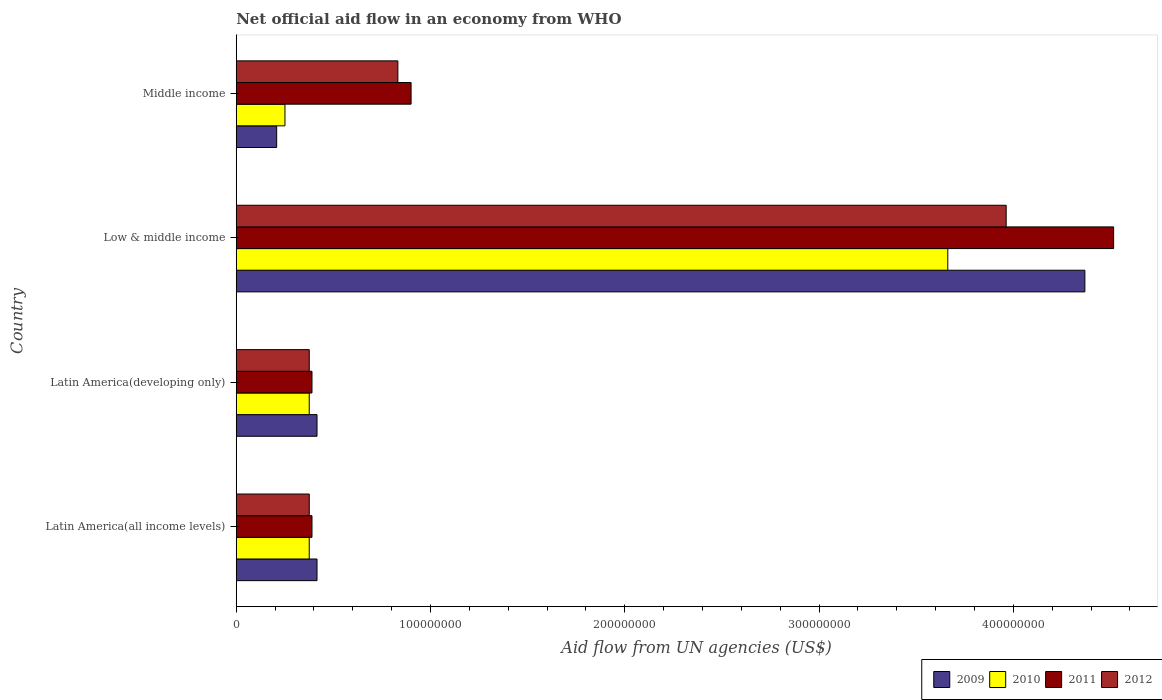Are the number of bars on each tick of the Y-axis equal?
Ensure brevity in your answer.  Yes. How many bars are there on the 2nd tick from the top?
Your answer should be very brief. 4. What is the label of the 3rd group of bars from the top?
Your answer should be very brief. Latin America(developing only). In how many cases, is the number of bars for a given country not equal to the number of legend labels?
Provide a succinct answer. 0. What is the net official aid flow in 2012 in Latin America(all income levels)?
Your answer should be compact. 3.76e+07. Across all countries, what is the maximum net official aid flow in 2009?
Offer a terse response. 4.37e+08. Across all countries, what is the minimum net official aid flow in 2012?
Offer a terse response. 3.76e+07. In which country was the net official aid flow in 2009 maximum?
Offer a very short reply. Low & middle income. In which country was the net official aid flow in 2009 minimum?
Provide a succinct answer. Middle income. What is the total net official aid flow in 2009 in the graph?
Keep it short and to the point. 5.41e+08. What is the difference between the net official aid flow in 2010 in Latin America(all income levels) and that in Low & middle income?
Your answer should be very brief. -3.29e+08. What is the difference between the net official aid flow in 2009 in Latin America(developing only) and the net official aid flow in 2011 in Low & middle income?
Your response must be concise. -4.10e+08. What is the average net official aid flow in 2010 per country?
Make the answer very short. 1.17e+08. What is the difference between the net official aid flow in 2012 and net official aid flow in 2011 in Low & middle income?
Your answer should be very brief. -5.53e+07. What is the ratio of the net official aid flow in 2010 in Low & middle income to that in Middle income?
Make the answer very short. 14.61. What is the difference between the highest and the second highest net official aid flow in 2010?
Your answer should be very brief. 3.29e+08. What is the difference between the highest and the lowest net official aid flow in 2011?
Ensure brevity in your answer.  4.13e+08. Is the sum of the net official aid flow in 2009 in Low & middle income and Middle income greater than the maximum net official aid flow in 2011 across all countries?
Ensure brevity in your answer.  Yes. Is it the case that in every country, the sum of the net official aid flow in 2010 and net official aid flow in 2011 is greater than the sum of net official aid flow in 2009 and net official aid flow in 2012?
Your response must be concise. No. What does the 4th bar from the top in Latin America(developing only) represents?
Provide a short and direct response. 2009. What does the 3rd bar from the bottom in Latin America(developing only) represents?
Provide a short and direct response. 2011. Is it the case that in every country, the sum of the net official aid flow in 2011 and net official aid flow in 2009 is greater than the net official aid flow in 2012?
Your response must be concise. Yes. How many bars are there?
Make the answer very short. 16. Are all the bars in the graph horizontal?
Keep it short and to the point. Yes. Does the graph contain any zero values?
Your answer should be compact. No. What is the title of the graph?
Offer a terse response. Net official aid flow in an economy from WHO. What is the label or title of the X-axis?
Give a very brief answer. Aid flow from UN agencies (US$). What is the label or title of the Y-axis?
Provide a succinct answer. Country. What is the Aid flow from UN agencies (US$) of 2009 in Latin America(all income levels)?
Offer a very short reply. 4.16e+07. What is the Aid flow from UN agencies (US$) of 2010 in Latin America(all income levels)?
Give a very brief answer. 3.76e+07. What is the Aid flow from UN agencies (US$) in 2011 in Latin America(all income levels)?
Offer a terse response. 3.90e+07. What is the Aid flow from UN agencies (US$) of 2012 in Latin America(all income levels)?
Your answer should be compact. 3.76e+07. What is the Aid flow from UN agencies (US$) of 2009 in Latin America(developing only)?
Offer a terse response. 4.16e+07. What is the Aid flow from UN agencies (US$) of 2010 in Latin America(developing only)?
Provide a short and direct response. 3.76e+07. What is the Aid flow from UN agencies (US$) of 2011 in Latin America(developing only)?
Make the answer very short. 3.90e+07. What is the Aid flow from UN agencies (US$) of 2012 in Latin America(developing only)?
Keep it short and to the point. 3.76e+07. What is the Aid flow from UN agencies (US$) of 2009 in Low & middle income?
Offer a terse response. 4.37e+08. What is the Aid flow from UN agencies (US$) in 2010 in Low & middle income?
Provide a succinct answer. 3.66e+08. What is the Aid flow from UN agencies (US$) of 2011 in Low & middle income?
Provide a succinct answer. 4.52e+08. What is the Aid flow from UN agencies (US$) in 2012 in Low & middle income?
Provide a succinct answer. 3.96e+08. What is the Aid flow from UN agencies (US$) in 2009 in Middle income?
Provide a succinct answer. 2.08e+07. What is the Aid flow from UN agencies (US$) of 2010 in Middle income?
Offer a terse response. 2.51e+07. What is the Aid flow from UN agencies (US$) of 2011 in Middle income?
Make the answer very short. 9.00e+07. What is the Aid flow from UN agencies (US$) in 2012 in Middle income?
Provide a short and direct response. 8.32e+07. Across all countries, what is the maximum Aid flow from UN agencies (US$) in 2009?
Ensure brevity in your answer.  4.37e+08. Across all countries, what is the maximum Aid flow from UN agencies (US$) of 2010?
Your answer should be compact. 3.66e+08. Across all countries, what is the maximum Aid flow from UN agencies (US$) in 2011?
Make the answer very short. 4.52e+08. Across all countries, what is the maximum Aid flow from UN agencies (US$) of 2012?
Ensure brevity in your answer.  3.96e+08. Across all countries, what is the minimum Aid flow from UN agencies (US$) in 2009?
Your response must be concise. 2.08e+07. Across all countries, what is the minimum Aid flow from UN agencies (US$) of 2010?
Your answer should be compact. 2.51e+07. Across all countries, what is the minimum Aid flow from UN agencies (US$) in 2011?
Provide a short and direct response. 3.90e+07. Across all countries, what is the minimum Aid flow from UN agencies (US$) of 2012?
Your response must be concise. 3.76e+07. What is the total Aid flow from UN agencies (US$) in 2009 in the graph?
Your response must be concise. 5.41e+08. What is the total Aid flow from UN agencies (US$) in 2010 in the graph?
Offer a terse response. 4.66e+08. What is the total Aid flow from UN agencies (US$) of 2011 in the graph?
Ensure brevity in your answer.  6.20e+08. What is the total Aid flow from UN agencies (US$) of 2012 in the graph?
Your response must be concise. 5.55e+08. What is the difference between the Aid flow from UN agencies (US$) of 2009 in Latin America(all income levels) and that in Latin America(developing only)?
Your answer should be compact. 0. What is the difference between the Aid flow from UN agencies (US$) of 2012 in Latin America(all income levels) and that in Latin America(developing only)?
Ensure brevity in your answer.  0. What is the difference between the Aid flow from UN agencies (US$) in 2009 in Latin America(all income levels) and that in Low & middle income?
Offer a very short reply. -3.95e+08. What is the difference between the Aid flow from UN agencies (US$) of 2010 in Latin America(all income levels) and that in Low & middle income?
Make the answer very short. -3.29e+08. What is the difference between the Aid flow from UN agencies (US$) in 2011 in Latin America(all income levels) and that in Low & middle income?
Provide a short and direct response. -4.13e+08. What is the difference between the Aid flow from UN agencies (US$) in 2012 in Latin America(all income levels) and that in Low & middle income?
Ensure brevity in your answer.  -3.59e+08. What is the difference between the Aid flow from UN agencies (US$) in 2009 in Latin America(all income levels) and that in Middle income?
Give a very brief answer. 2.08e+07. What is the difference between the Aid flow from UN agencies (US$) of 2010 in Latin America(all income levels) and that in Middle income?
Keep it short and to the point. 1.25e+07. What is the difference between the Aid flow from UN agencies (US$) in 2011 in Latin America(all income levels) and that in Middle income?
Your answer should be very brief. -5.10e+07. What is the difference between the Aid flow from UN agencies (US$) in 2012 in Latin America(all income levels) and that in Middle income?
Keep it short and to the point. -4.56e+07. What is the difference between the Aid flow from UN agencies (US$) in 2009 in Latin America(developing only) and that in Low & middle income?
Your answer should be very brief. -3.95e+08. What is the difference between the Aid flow from UN agencies (US$) in 2010 in Latin America(developing only) and that in Low & middle income?
Your answer should be compact. -3.29e+08. What is the difference between the Aid flow from UN agencies (US$) of 2011 in Latin America(developing only) and that in Low & middle income?
Your response must be concise. -4.13e+08. What is the difference between the Aid flow from UN agencies (US$) of 2012 in Latin America(developing only) and that in Low & middle income?
Keep it short and to the point. -3.59e+08. What is the difference between the Aid flow from UN agencies (US$) in 2009 in Latin America(developing only) and that in Middle income?
Give a very brief answer. 2.08e+07. What is the difference between the Aid flow from UN agencies (US$) in 2010 in Latin America(developing only) and that in Middle income?
Give a very brief answer. 1.25e+07. What is the difference between the Aid flow from UN agencies (US$) in 2011 in Latin America(developing only) and that in Middle income?
Offer a terse response. -5.10e+07. What is the difference between the Aid flow from UN agencies (US$) of 2012 in Latin America(developing only) and that in Middle income?
Give a very brief answer. -4.56e+07. What is the difference between the Aid flow from UN agencies (US$) of 2009 in Low & middle income and that in Middle income?
Offer a terse response. 4.16e+08. What is the difference between the Aid flow from UN agencies (US$) in 2010 in Low & middle income and that in Middle income?
Make the answer very short. 3.41e+08. What is the difference between the Aid flow from UN agencies (US$) in 2011 in Low & middle income and that in Middle income?
Your response must be concise. 3.62e+08. What is the difference between the Aid flow from UN agencies (US$) in 2012 in Low & middle income and that in Middle income?
Offer a terse response. 3.13e+08. What is the difference between the Aid flow from UN agencies (US$) of 2009 in Latin America(all income levels) and the Aid flow from UN agencies (US$) of 2010 in Latin America(developing only)?
Keep it short and to the point. 4.01e+06. What is the difference between the Aid flow from UN agencies (US$) in 2009 in Latin America(all income levels) and the Aid flow from UN agencies (US$) in 2011 in Latin America(developing only)?
Your answer should be compact. 2.59e+06. What is the difference between the Aid flow from UN agencies (US$) in 2009 in Latin America(all income levels) and the Aid flow from UN agencies (US$) in 2012 in Latin America(developing only)?
Keep it short and to the point. 3.99e+06. What is the difference between the Aid flow from UN agencies (US$) in 2010 in Latin America(all income levels) and the Aid flow from UN agencies (US$) in 2011 in Latin America(developing only)?
Ensure brevity in your answer.  -1.42e+06. What is the difference between the Aid flow from UN agencies (US$) in 2010 in Latin America(all income levels) and the Aid flow from UN agencies (US$) in 2012 in Latin America(developing only)?
Your answer should be compact. -2.00e+04. What is the difference between the Aid flow from UN agencies (US$) of 2011 in Latin America(all income levels) and the Aid flow from UN agencies (US$) of 2012 in Latin America(developing only)?
Provide a succinct answer. 1.40e+06. What is the difference between the Aid flow from UN agencies (US$) of 2009 in Latin America(all income levels) and the Aid flow from UN agencies (US$) of 2010 in Low & middle income?
Provide a succinct answer. -3.25e+08. What is the difference between the Aid flow from UN agencies (US$) in 2009 in Latin America(all income levels) and the Aid flow from UN agencies (US$) in 2011 in Low & middle income?
Your answer should be very brief. -4.10e+08. What is the difference between the Aid flow from UN agencies (US$) in 2009 in Latin America(all income levels) and the Aid flow from UN agencies (US$) in 2012 in Low & middle income?
Make the answer very short. -3.55e+08. What is the difference between the Aid flow from UN agencies (US$) of 2010 in Latin America(all income levels) and the Aid flow from UN agencies (US$) of 2011 in Low & middle income?
Offer a very short reply. -4.14e+08. What is the difference between the Aid flow from UN agencies (US$) in 2010 in Latin America(all income levels) and the Aid flow from UN agencies (US$) in 2012 in Low & middle income?
Ensure brevity in your answer.  -3.59e+08. What is the difference between the Aid flow from UN agencies (US$) of 2011 in Latin America(all income levels) and the Aid flow from UN agencies (US$) of 2012 in Low & middle income?
Provide a succinct answer. -3.57e+08. What is the difference between the Aid flow from UN agencies (US$) in 2009 in Latin America(all income levels) and the Aid flow from UN agencies (US$) in 2010 in Middle income?
Make the answer very short. 1.65e+07. What is the difference between the Aid flow from UN agencies (US$) in 2009 in Latin America(all income levels) and the Aid flow from UN agencies (US$) in 2011 in Middle income?
Offer a terse response. -4.84e+07. What is the difference between the Aid flow from UN agencies (US$) in 2009 in Latin America(all income levels) and the Aid flow from UN agencies (US$) in 2012 in Middle income?
Your response must be concise. -4.16e+07. What is the difference between the Aid flow from UN agencies (US$) of 2010 in Latin America(all income levels) and the Aid flow from UN agencies (US$) of 2011 in Middle income?
Keep it short and to the point. -5.24e+07. What is the difference between the Aid flow from UN agencies (US$) of 2010 in Latin America(all income levels) and the Aid flow from UN agencies (US$) of 2012 in Middle income?
Make the answer very short. -4.56e+07. What is the difference between the Aid flow from UN agencies (US$) in 2011 in Latin America(all income levels) and the Aid flow from UN agencies (US$) in 2012 in Middle income?
Provide a succinct answer. -4.42e+07. What is the difference between the Aid flow from UN agencies (US$) of 2009 in Latin America(developing only) and the Aid flow from UN agencies (US$) of 2010 in Low & middle income?
Provide a short and direct response. -3.25e+08. What is the difference between the Aid flow from UN agencies (US$) in 2009 in Latin America(developing only) and the Aid flow from UN agencies (US$) in 2011 in Low & middle income?
Provide a succinct answer. -4.10e+08. What is the difference between the Aid flow from UN agencies (US$) of 2009 in Latin America(developing only) and the Aid flow from UN agencies (US$) of 2012 in Low & middle income?
Your answer should be compact. -3.55e+08. What is the difference between the Aid flow from UN agencies (US$) of 2010 in Latin America(developing only) and the Aid flow from UN agencies (US$) of 2011 in Low & middle income?
Offer a terse response. -4.14e+08. What is the difference between the Aid flow from UN agencies (US$) in 2010 in Latin America(developing only) and the Aid flow from UN agencies (US$) in 2012 in Low & middle income?
Offer a terse response. -3.59e+08. What is the difference between the Aid flow from UN agencies (US$) in 2011 in Latin America(developing only) and the Aid flow from UN agencies (US$) in 2012 in Low & middle income?
Your answer should be very brief. -3.57e+08. What is the difference between the Aid flow from UN agencies (US$) of 2009 in Latin America(developing only) and the Aid flow from UN agencies (US$) of 2010 in Middle income?
Keep it short and to the point. 1.65e+07. What is the difference between the Aid flow from UN agencies (US$) in 2009 in Latin America(developing only) and the Aid flow from UN agencies (US$) in 2011 in Middle income?
Ensure brevity in your answer.  -4.84e+07. What is the difference between the Aid flow from UN agencies (US$) of 2009 in Latin America(developing only) and the Aid flow from UN agencies (US$) of 2012 in Middle income?
Provide a short and direct response. -4.16e+07. What is the difference between the Aid flow from UN agencies (US$) in 2010 in Latin America(developing only) and the Aid flow from UN agencies (US$) in 2011 in Middle income?
Offer a very short reply. -5.24e+07. What is the difference between the Aid flow from UN agencies (US$) in 2010 in Latin America(developing only) and the Aid flow from UN agencies (US$) in 2012 in Middle income?
Your answer should be very brief. -4.56e+07. What is the difference between the Aid flow from UN agencies (US$) in 2011 in Latin America(developing only) and the Aid flow from UN agencies (US$) in 2012 in Middle income?
Keep it short and to the point. -4.42e+07. What is the difference between the Aid flow from UN agencies (US$) of 2009 in Low & middle income and the Aid flow from UN agencies (US$) of 2010 in Middle income?
Make the answer very short. 4.12e+08. What is the difference between the Aid flow from UN agencies (US$) of 2009 in Low & middle income and the Aid flow from UN agencies (US$) of 2011 in Middle income?
Keep it short and to the point. 3.47e+08. What is the difference between the Aid flow from UN agencies (US$) of 2009 in Low & middle income and the Aid flow from UN agencies (US$) of 2012 in Middle income?
Provide a succinct answer. 3.54e+08. What is the difference between the Aid flow from UN agencies (US$) of 2010 in Low & middle income and the Aid flow from UN agencies (US$) of 2011 in Middle income?
Ensure brevity in your answer.  2.76e+08. What is the difference between the Aid flow from UN agencies (US$) in 2010 in Low & middle income and the Aid flow from UN agencies (US$) in 2012 in Middle income?
Provide a succinct answer. 2.83e+08. What is the difference between the Aid flow from UN agencies (US$) of 2011 in Low & middle income and the Aid flow from UN agencies (US$) of 2012 in Middle income?
Offer a terse response. 3.68e+08. What is the average Aid flow from UN agencies (US$) in 2009 per country?
Your answer should be compact. 1.35e+08. What is the average Aid flow from UN agencies (US$) of 2010 per country?
Your response must be concise. 1.17e+08. What is the average Aid flow from UN agencies (US$) in 2011 per country?
Your response must be concise. 1.55e+08. What is the average Aid flow from UN agencies (US$) in 2012 per country?
Provide a short and direct response. 1.39e+08. What is the difference between the Aid flow from UN agencies (US$) in 2009 and Aid flow from UN agencies (US$) in 2010 in Latin America(all income levels)?
Keep it short and to the point. 4.01e+06. What is the difference between the Aid flow from UN agencies (US$) of 2009 and Aid flow from UN agencies (US$) of 2011 in Latin America(all income levels)?
Keep it short and to the point. 2.59e+06. What is the difference between the Aid flow from UN agencies (US$) of 2009 and Aid flow from UN agencies (US$) of 2012 in Latin America(all income levels)?
Provide a short and direct response. 3.99e+06. What is the difference between the Aid flow from UN agencies (US$) of 2010 and Aid flow from UN agencies (US$) of 2011 in Latin America(all income levels)?
Provide a succinct answer. -1.42e+06. What is the difference between the Aid flow from UN agencies (US$) in 2010 and Aid flow from UN agencies (US$) in 2012 in Latin America(all income levels)?
Keep it short and to the point. -2.00e+04. What is the difference between the Aid flow from UN agencies (US$) of 2011 and Aid flow from UN agencies (US$) of 2012 in Latin America(all income levels)?
Offer a very short reply. 1.40e+06. What is the difference between the Aid flow from UN agencies (US$) in 2009 and Aid flow from UN agencies (US$) in 2010 in Latin America(developing only)?
Provide a succinct answer. 4.01e+06. What is the difference between the Aid flow from UN agencies (US$) in 2009 and Aid flow from UN agencies (US$) in 2011 in Latin America(developing only)?
Offer a terse response. 2.59e+06. What is the difference between the Aid flow from UN agencies (US$) in 2009 and Aid flow from UN agencies (US$) in 2012 in Latin America(developing only)?
Offer a terse response. 3.99e+06. What is the difference between the Aid flow from UN agencies (US$) of 2010 and Aid flow from UN agencies (US$) of 2011 in Latin America(developing only)?
Provide a succinct answer. -1.42e+06. What is the difference between the Aid flow from UN agencies (US$) of 2011 and Aid flow from UN agencies (US$) of 2012 in Latin America(developing only)?
Your answer should be compact. 1.40e+06. What is the difference between the Aid flow from UN agencies (US$) in 2009 and Aid flow from UN agencies (US$) in 2010 in Low & middle income?
Offer a terse response. 7.06e+07. What is the difference between the Aid flow from UN agencies (US$) of 2009 and Aid flow from UN agencies (US$) of 2011 in Low & middle income?
Offer a very short reply. -1.48e+07. What is the difference between the Aid flow from UN agencies (US$) of 2009 and Aid flow from UN agencies (US$) of 2012 in Low & middle income?
Your answer should be very brief. 4.05e+07. What is the difference between the Aid flow from UN agencies (US$) of 2010 and Aid flow from UN agencies (US$) of 2011 in Low & middle income?
Your response must be concise. -8.54e+07. What is the difference between the Aid flow from UN agencies (US$) of 2010 and Aid flow from UN agencies (US$) of 2012 in Low & middle income?
Give a very brief answer. -3.00e+07. What is the difference between the Aid flow from UN agencies (US$) in 2011 and Aid flow from UN agencies (US$) in 2012 in Low & middle income?
Ensure brevity in your answer.  5.53e+07. What is the difference between the Aid flow from UN agencies (US$) in 2009 and Aid flow from UN agencies (US$) in 2010 in Middle income?
Your answer should be very brief. -4.27e+06. What is the difference between the Aid flow from UN agencies (US$) of 2009 and Aid flow from UN agencies (US$) of 2011 in Middle income?
Provide a succinct answer. -6.92e+07. What is the difference between the Aid flow from UN agencies (US$) of 2009 and Aid flow from UN agencies (US$) of 2012 in Middle income?
Offer a terse response. -6.24e+07. What is the difference between the Aid flow from UN agencies (US$) of 2010 and Aid flow from UN agencies (US$) of 2011 in Middle income?
Your response must be concise. -6.49e+07. What is the difference between the Aid flow from UN agencies (US$) of 2010 and Aid flow from UN agencies (US$) of 2012 in Middle income?
Your response must be concise. -5.81e+07. What is the difference between the Aid flow from UN agencies (US$) of 2011 and Aid flow from UN agencies (US$) of 2012 in Middle income?
Provide a succinct answer. 6.80e+06. What is the ratio of the Aid flow from UN agencies (US$) of 2012 in Latin America(all income levels) to that in Latin America(developing only)?
Your answer should be very brief. 1. What is the ratio of the Aid flow from UN agencies (US$) of 2009 in Latin America(all income levels) to that in Low & middle income?
Make the answer very short. 0.1. What is the ratio of the Aid flow from UN agencies (US$) of 2010 in Latin America(all income levels) to that in Low & middle income?
Keep it short and to the point. 0.1. What is the ratio of the Aid flow from UN agencies (US$) in 2011 in Latin America(all income levels) to that in Low & middle income?
Give a very brief answer. 0.09. What is the ratio of the Aid flow from UN agencies (US$) of 2012 in Latin America(all income levels) to that in Low & middle income?
Provide a short and direct response. 0.09. What is the ratio of the Aid flow from UN agencies (US$) in 2009 in Latin America(all income levels) to that in Middle income?
Offer a terse response. 2. What is the ratio of the Aid flow from UN agencies (US$) in 2010 in Latin America(all income levels) to that in Middle income?
Your answer should be compact. 1.5. What is the ratio of the Aid flow from UN agencies (US$) of 2011 in Latin America(all income levels) to that in Middle income?
Provide a short and direct response. 0.43. What is the ratio of the Aid flow from UN agencies (US$) in 2012 in Latin America(all income levels) to that in Middle income?
Provide a succinct answer. 0.45. What is the ratio of the Aid flow from UN agencies (US$) in 2009 in Latin America(developing only) to that in Low & middle income?
Ensure brevity in your answer.  0.1. What is the ratio of the Aid flow from UN agencies (US$) of 2010 in Latin America(developing only) to that in Low & middle income?
Provide a succinct answer. 0.1. What is the ratio of the Aid flow from UN agencies (US$) in 2011 in Latin America(developing only) to that in Low & middle income?
Make the answer very short. 0.09. What is the ratio of the Aid flow from UN agencies (US$) of 2012 in Latin America(developing only) to that in Low & middle income?
Ensure brevity in your answer.  0.09. What is the ratio of the Aid flow from UN agencies (US$) in 2009 in Latin America(developing only) to that in Middle income?
Provide a short and direct response. 2. What is the ratio of the Aid flow from UN agencies (US$) of 2010 in Latin America(developing only) to that in Middle income?
Provide a short and direct response. 1.5. What is the ratio of the Aid flow from UN agencies (US$) of 2011 in Latin America(developing only) to that in Middle income?
Provide a succinct answer. 0.43. What is the ratio of the Aid flow from UN agencies (US$) of 2012 in Latin America(developing only) to that in Middle income?
Offer a terse response. 0.45. What is the ratio of the Aid flow from UN agencies (US$) in 2009 in Low & middle income to that in Middle income?
Ensure brevity in your answer.  21. What is the ratio of the Aid flow from UN agencies (US$) of 2010 in Low & middle income to that in Middle income?
Your answer should be very brief. 14.61. What is the ratio of the Aid flow from UN agencies (US$) in 2011 in Low & middle income to that in Middle income?
Provide a succinct answer. 5.02. What is the ratio of the Aid flow from UN agencies (US$) of 2012 in Low & middle income to that in Middle income?
Your response must be concise. 4.76. What is the difference between the highest and the second highest Aid flow from UN agencies (US$) in 2009?
Provide a succinct answer. 3.95e+08. What is the difference between the highest and the second highest Aid flow from UN agencies (US$) of 2010?
Make the answer very short. 3.29e+08. What is the difference between the highest and the second highest Aid flow from UN agencies (US$) in 2011?
Offer a very short reply. 3.62e+08. What is the difference between the highest and the second highest Aid flow from UN agencies (US$) of 2012?
Offer a terse response. 3.13e+08. What is the difference between the highest and the lowest Aid flow from UN agencies (US$) of 2009?
Keep it short and to the point. 4.16e+08. What is the difference between the highest and the lowest Aid flow from UN agencies (US$) of 2010?
Keep it short and to the point. 3.41e+08. What is the difference between the highest and the lowest Aid flow from UN agencies (US$) in 2011?
Provide a short and direct response. 4.13e+08. What is the difference between the highest and the lowest Aid flow from UN agencies (US$) in 2012?
Provide a short and direct response. 3.59e+08. 